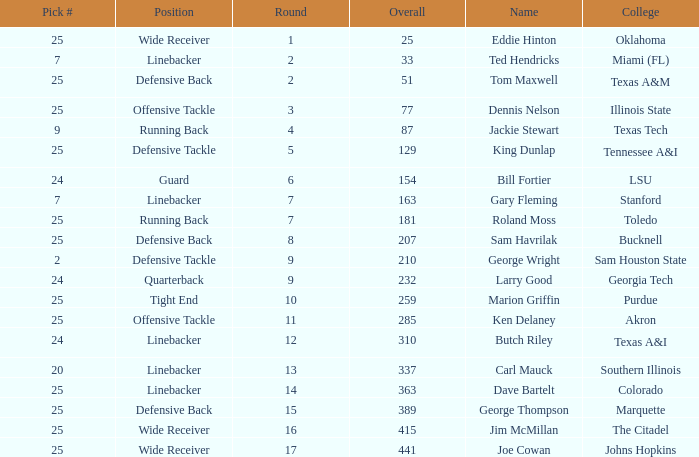College of lsu has how many rounds? 1.0. 